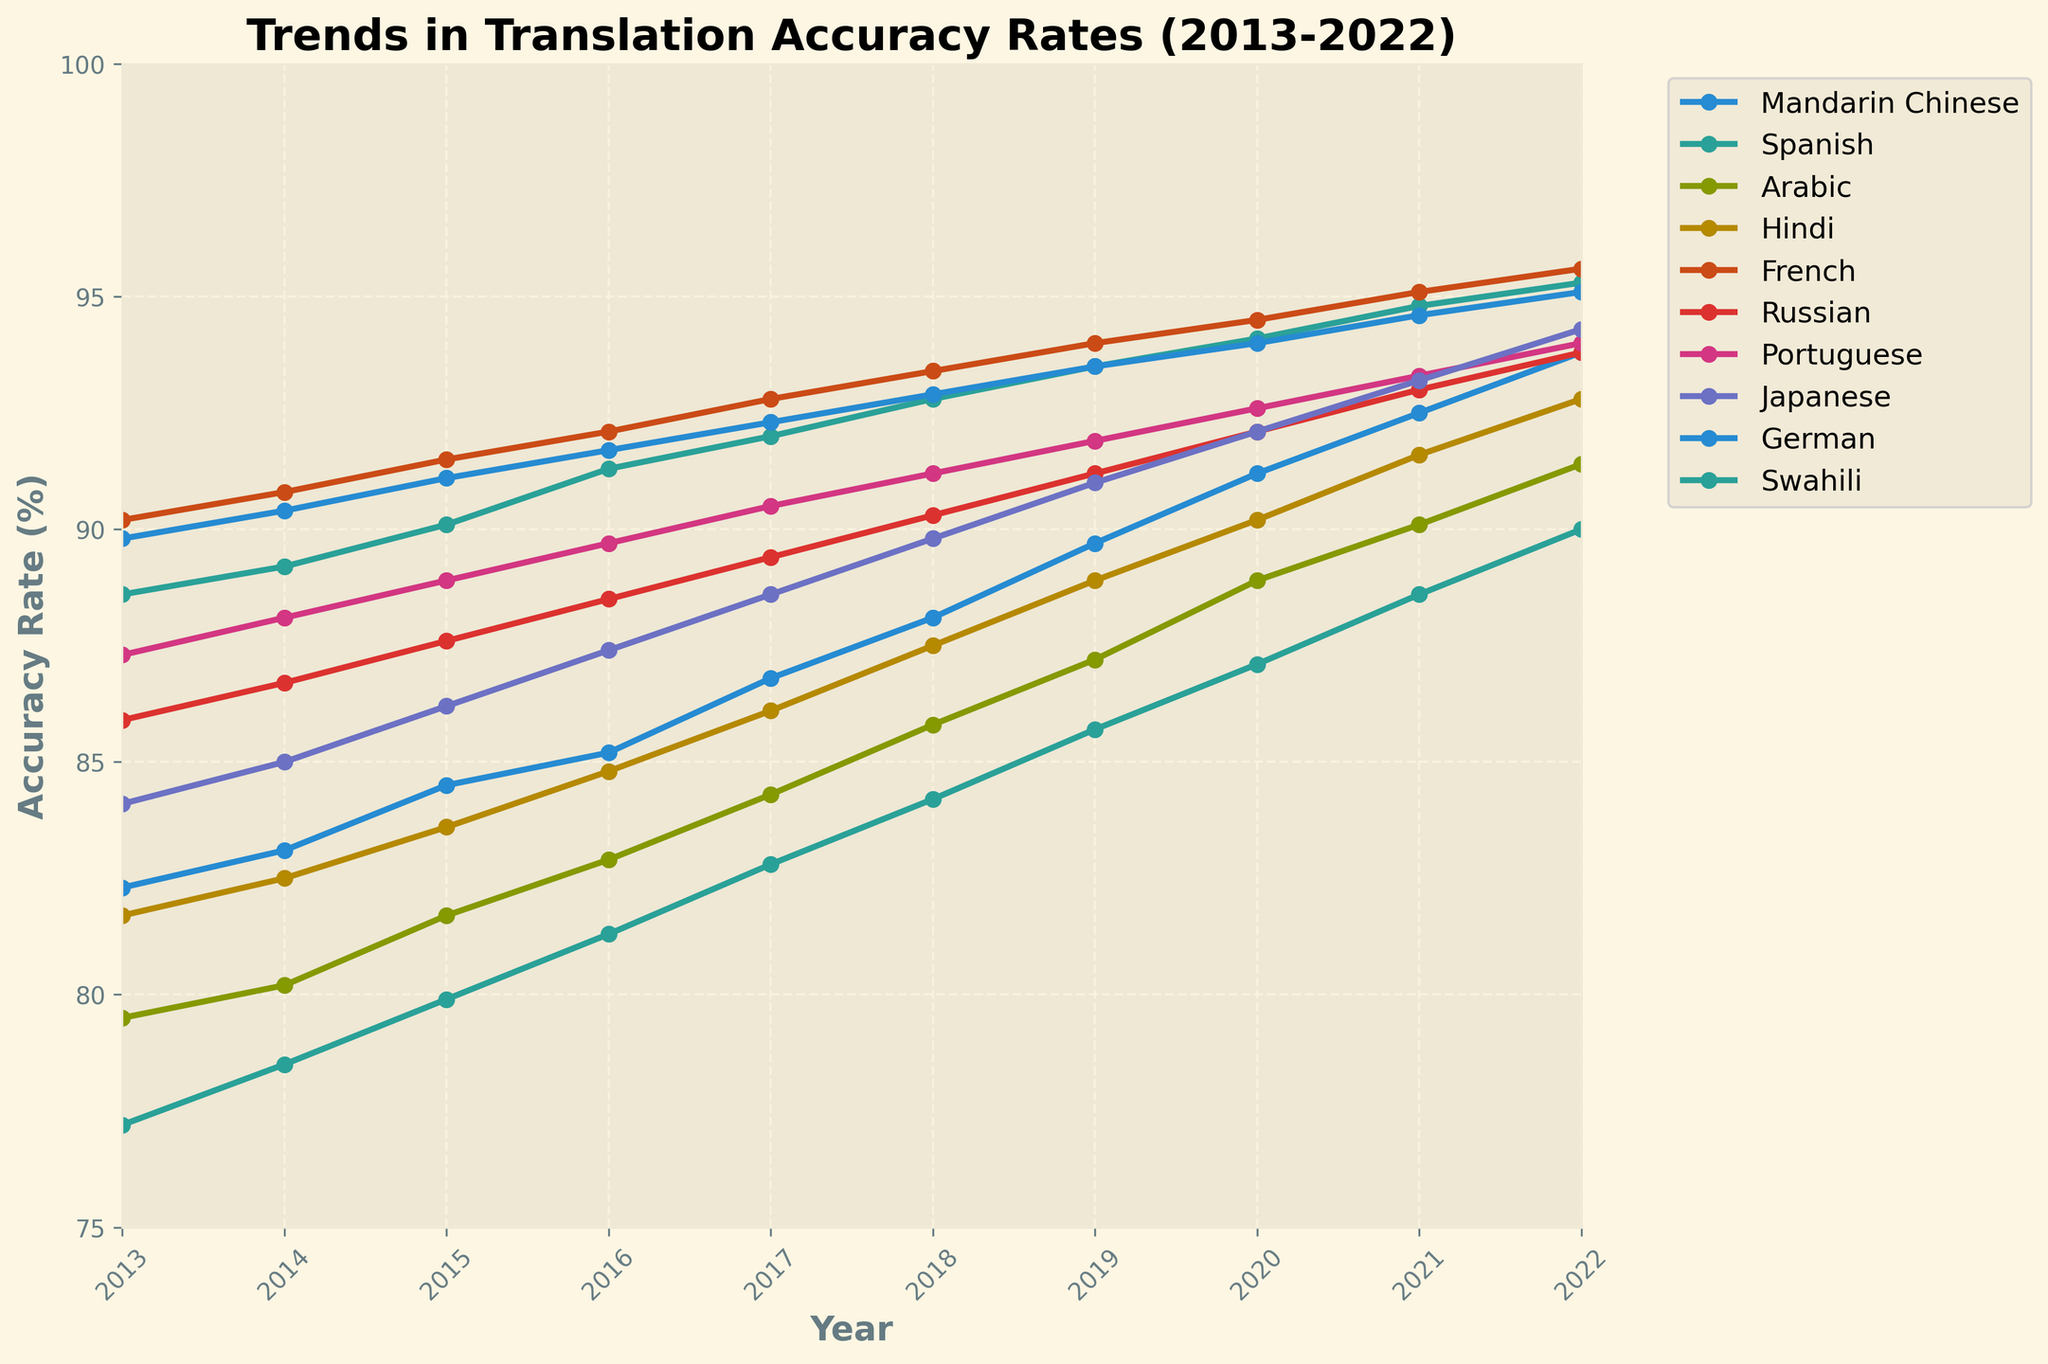what language had the highest accuracy rate in 2022? To determine which language had the highest accuracy rate in 2022, look at the accuracy rates for all languages in that year and find the maximum value. French has the highest rate at 95.6%.
Answer: French Which language showed the greatest increase in translation accuracy from 2013 to 2022? Calculate the difference in accuracy between 2022 and 2013 for each language and compare them. Swahili had an increase of 12.8% (90.0 - 77.2), which is the largest.
Answer: Swahili How did the accuracy rate for Mandarin Chinese change from 2015 to 2020? Look at the accuracy rates for Mandarin Chinese in 2015 (84.5) and 2020 (91.2), then subtract the earlier value from the later value. The increase is 6.7% (91.2 - 84.5).
Answer: It increased by 6.7% Which two languages had the closest accuracy rates in 2018? Compare the accuracy rates for all languages in 2018 to find the pair with the smallest difference. Russian (90.3%) and Portuguese (91.2%) have the closest rates, differing by 0.9%.
Answer: Russian and Portuguese What is the average translation accuracy rate for Hindi over the decade? Add the accuracy rates for Hindi from 2013 to 2022 and divide by the number of years (10). The sum is 858.8, so the average is 858.8 / 10 = 85.88%.
Answer: 85.88% In which year did Japanese reach an accuracy rate above 90% for the first time? Examine the data for Japanese year by year until the accuracy rate exceeds 90%. This happens in 2019 when the rate is 91.0%.
Answer: 2019 Which language had a lower accuracy rate in 2022 than French had in 2013? Check the accuracy rates of all languages in 2022 and compare them with French's 2013 rate (90.2%). Swahili, Arabic, and Hindi had lower rates (90.0%, 91.4%, and 92.8% respectively).
Answer: Swahili What is the difference in translation accuracy between the highest and lowest accuracy rates in 2017? Subtract the lowest accuracy rate in 2017 (Swahili: 82.8%) from the highest (French: 92.8%). The difference is 10%.
Answer: 10% Which language showed the most consistent accuracy rate improvement over the decade? Assess the overall trend and variability in improvement. French, with rates steadily increasing every year from 90.2% to 95.6%, shows the most consistent improvement.
Answer: French 